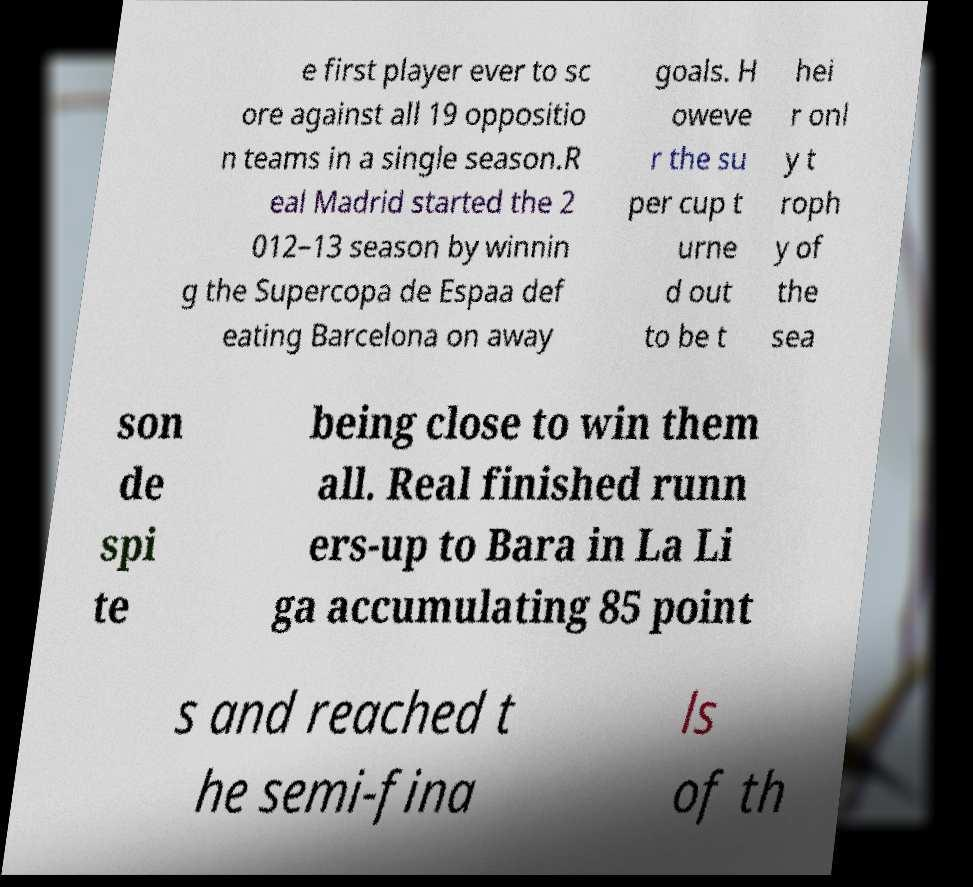For documentation purposes, I need the text within this image transcribed. Could you provide that? e first player ever to sc ore against all 19 oppositio n teams in a single season.R eal Madrid started the 2 012–13 season by winnin g the Supercopa de Espaa def eating Barcelona on away goals. H oweve r the su per cup t urne d out to be t hei r onl y t roph y of the sea son de spi te being close to win them all. Real finished runn ers-up to Bara in La Li ga accumulating 85 point s and reached t he semi-fina ls of th 